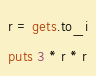Convert code to text. <code><loc_0><loc_0><loc_500><loc_500><_Ruby_>r = gets.to_i
puts 3 * r * r
</code> 